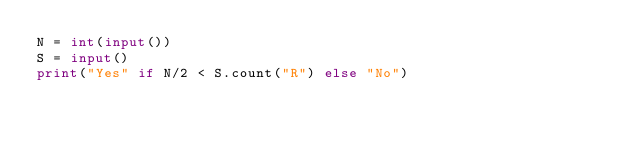<code> <loc_0><loc_0><loc_500><loc_500><_Python_>N = int(input())
S = input()
print("Yes" if N/2 < S.count("R") else "No")
</code> 